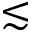<formula> <loc_0><loc_0><loc_500><loc_500>\lesssim</formula> 